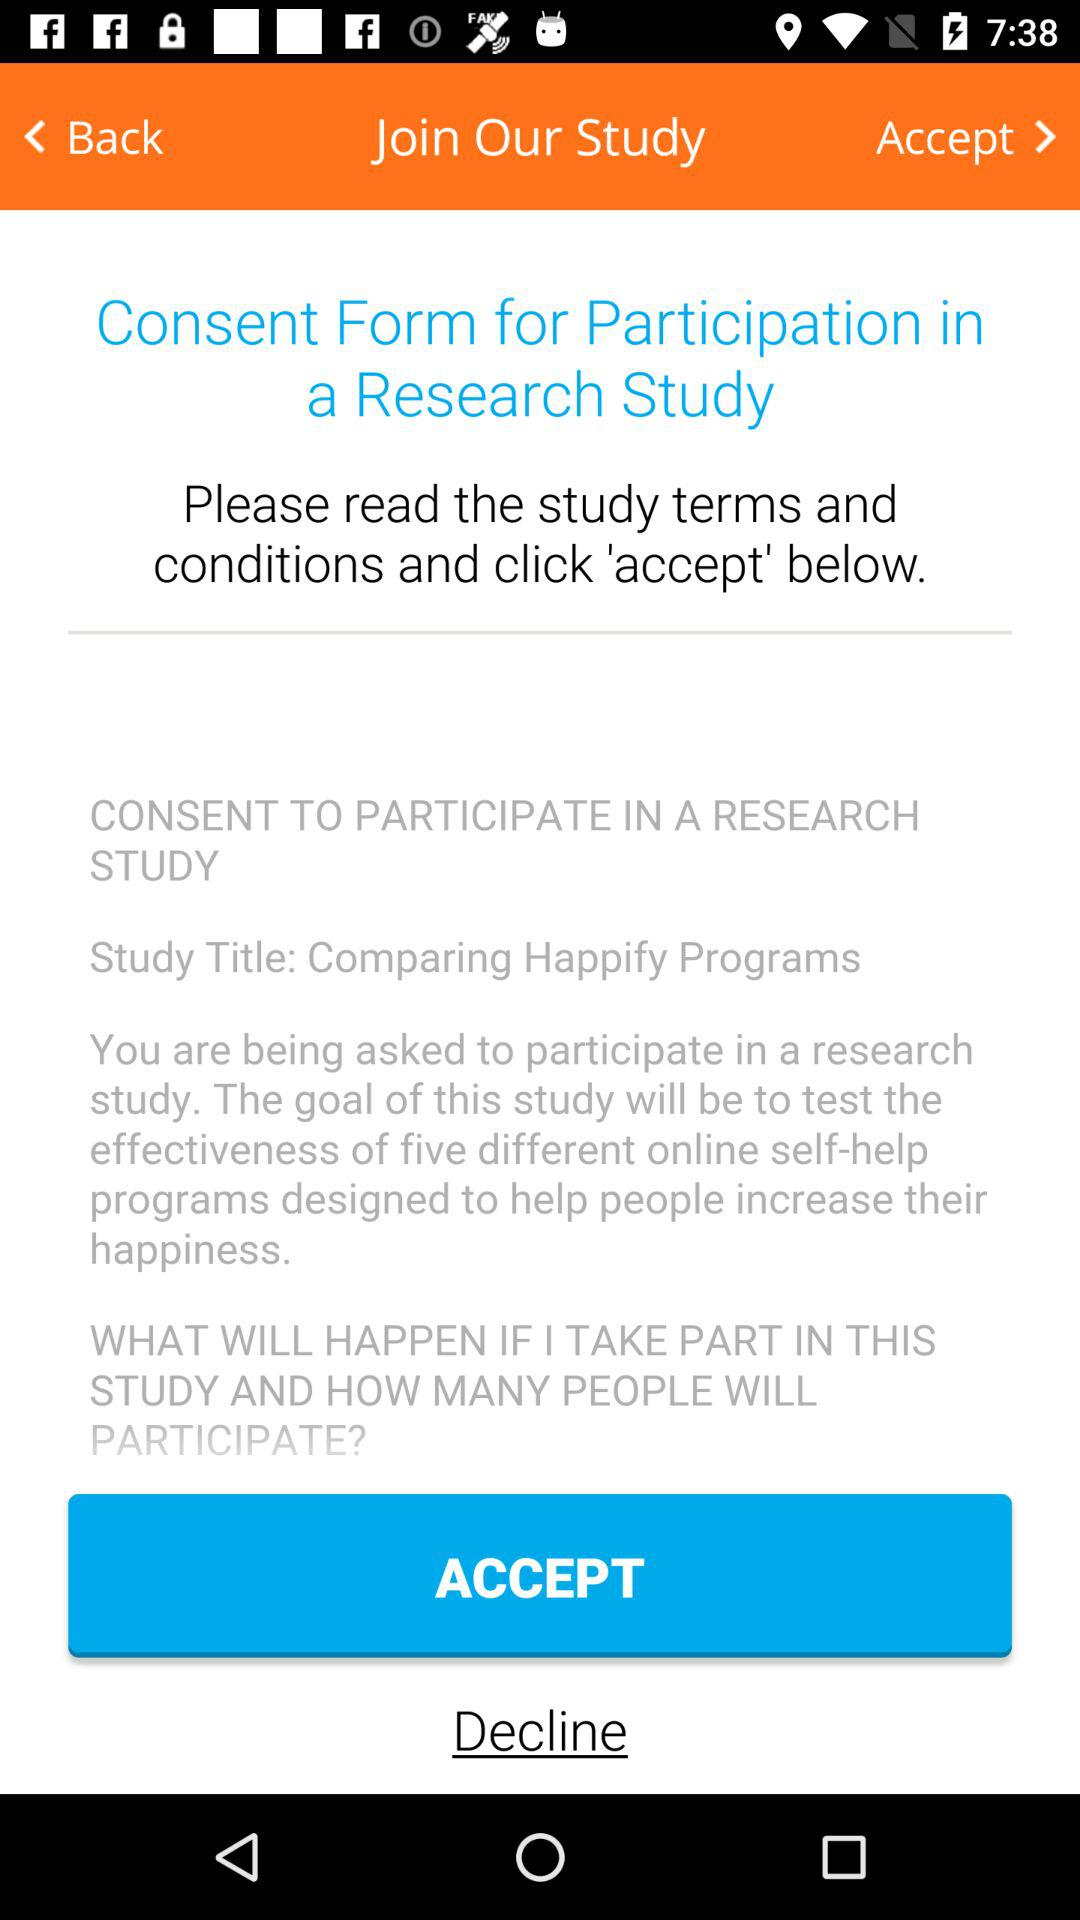What is the given study title? The given study title is "Comparing Happify Programs". 